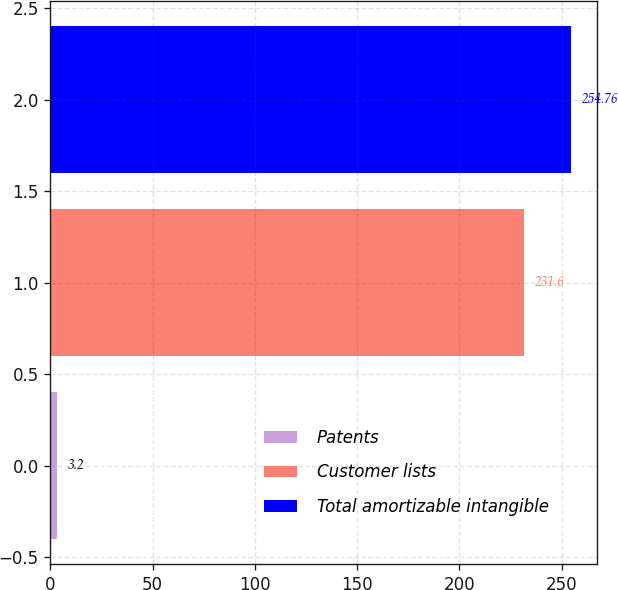<chart> <loc_0><loc_0><loc_500><loc_500><bar_chart><fcel>Patents<fcel>Customer lists<fcel>Total amortizable intangible<nl><fcel>3.2<fcel>231.6<fcel>254.76<nl></chart> 